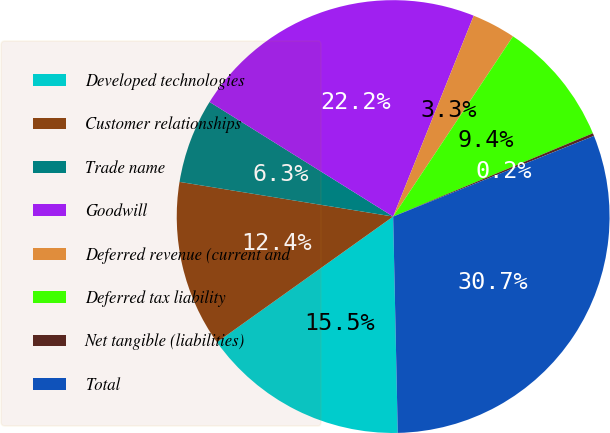Convert chart to OTSL. <chart><loc_0><loc_0><loc_500><loc_500><pie_chart><fcel>Developed technologies<fcel>Customer relationships<fcel>Trade name<fcel>Goodwill<fcel>Deferred revenue (current and<fcel>Deferred tax liability<fcel>Net tangible (liabilities)<fcel>Total<nl><fcel>15.48%<fcel>12.42%<fcel>6.32%<fcel>22.19%<fcel>3.27%<fcel>9.37%<fcel>0.21%<fcel>30.74%<nl></chart> 